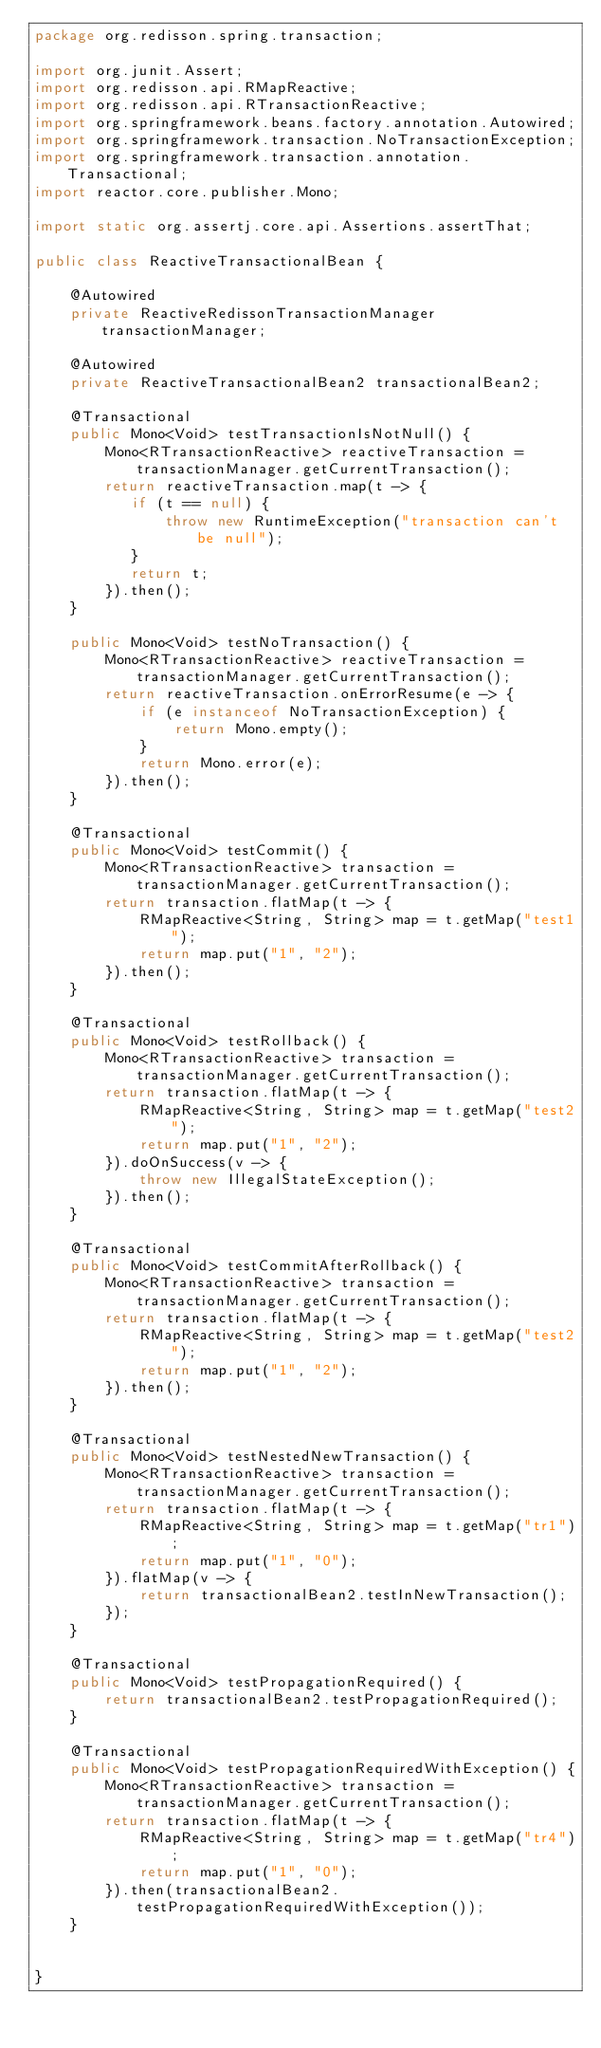<code> <loc_0><loc_0><loc_500><loc_500><_Java_>package org.redisson.spring.transaction;

import org.junit.Assert;
import org.redisson.api.RMapReactive;
import org.redisson.api.RTransactionReactive;
import org.springframework.beans.factory.annotation.Autowired;
import org.springframework.transaction.NoTransactionException;
import org.springframework.transaction.annotation.Transactional;
import reactor.core.publisher.Mono;

import static org.assertj.core.api.Assertions.assertThat;

public class ReactiveTransactionalBean {

    @Autowired
    private ReactiveRedissonTransactionManager transactionManager;
    
    @Autowired
    private ReactiveTransactionalBean2 transactionalBean2;
    
    @Transactional
    public Mono<Void> testTransactionIsNotNull() {
        Mono<RTransactionReactive> reactiveTransaction = transactionManager.getCurrentTransaction();
        return reactiveTransaction.map(t -> {
           if (t == null) {
               throw new RuntimeException("transaction can't be null");
           }
           return t;
        }).then();
    }

    public Mono<Void> testNoTransaction() {
        Mono<RTransactionReactive> reactiveTransaction = transactionManager.getCurrentTransaction();
        return reactiveTransaction.onErrorResume(e -> {
            if (e instanceof NoTransactionException) {
                return Mono.empty();
            }
            return Mono.error(e);
        }).then();
    }

    @Transactional
    public Mono<Void> testCommit() {
        Mono<RTransactionReactive> transaction = transactionManager.getCurrentTransaction();
        return transaction.flatMap(t -> {
            RMapReactive<String, String> map = t.getMap("test1");
            return map.put("1", "2");
        }).then();
    }
    
    @Transactional
    public Mono<Void> testRollback() {
        Mono<RTransactionReactive> transaction = transactionManager.getCurrentTransaction();
        return transaction.flatMap(t -> {
            RMapReactive<String, String> map = t.getMap("test2");
            return map.put("1", "2");
        }).doOnSuccess(v -> {
            throw new IllegalStateException();
        }).then();
    }

    @Transactional
    public Mono<Void> testCommitAfterRollback() {
        Mono<RTransactionReactive> transaction = transactionManager.getCurrentTransaction();
        return transaction.flatMap(t -> {
            RMapReactive<String, String> map = t.getMap("test2");
            return map.put("1", "2");
        }).then();
    }

    @Transactional
    public Mono<Void> testNestedNewTransaction() {
        Mono<RTransactionReactive> transaction = transactionManager.getCurrentTransaction();
        return transaction.flatMap(t -> {
            RMapReactive<String, String> map = t.getMap("tr1");
            return map.put("1", "0");
        }).flatMap(v -> {
            return transactionalBean2.testInNewTransaction();
        });
    }

    @Transactional
    public Mono<Void> testPropagationRequired() {
        return transactionalBean2.testPropagationRequired();
    }

    @Transactional
    public Mono<Void> testPropagationRequiredWithException() {
        Mono<RTransactionReactive> transaction = transactionManager.getCurrentTransaction();
        return transaction.flatMap(t -> {
            RMapReactive<String, String> map = t.getMap("tr4");
            return map.put("1", "0");
        }).then(transactionalBean2.testPropagationRequiredWithException());
    }


}
</code> 